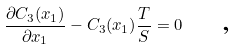<formula> <loc_0><loc_0><loc_500><loc_500>\frac { \partial C _ { 3 } ( x _ { 1 } ) } { \partial x _ { 1 } } - C _ { 3 } ( x _ { 1 } ) \frac { T } { S } = 0 \text { \quad ,}</formula> 